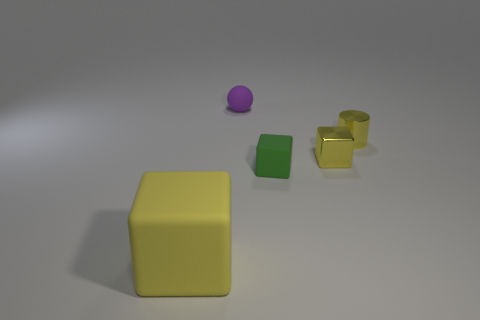Is there any other thing that is the same size as the yellow rubber object?
Ensure brevity in your answer.  No. The matte object that is the same color as the tiny metallic cube is what size?
Ensure brevity in your answer.  Large. There is a yellow metallic cube; how many tiny metallic blocks are behind it?
Provide a short and direct response. 0. What is the size of the yellow rubber object that is in front of the thing behind the tiny metallic cylinder?
Offer a very short reply. Large. There is a yellow metallic object that is in front of the yellow cylinder; is it the same shape as the small yellow object behind the tiny yellow block?
Provide a short and direct response. No. There is a tiny matte object that is left of the matte block behind the large matte thing; what is its shape?
Your answer should be very brief. Sphere. What is the size of the object that is on the left side of the tiny green block and in front of the small sphere?
Offer a terse response. Large. There is a large thing; is its shape the same as the matte object on the right side of the purple rubber thing?
Provide a succinct answer. Yes. There is another rubber thing that is the same shape as the small green rubber object; what size is it?
Offer a very short reply. Large. There is a metal cylinder; is it the same color as the small shiny object in front of the tiny yellow metallic cylinder?
Provide a short and direct response. Yes. 